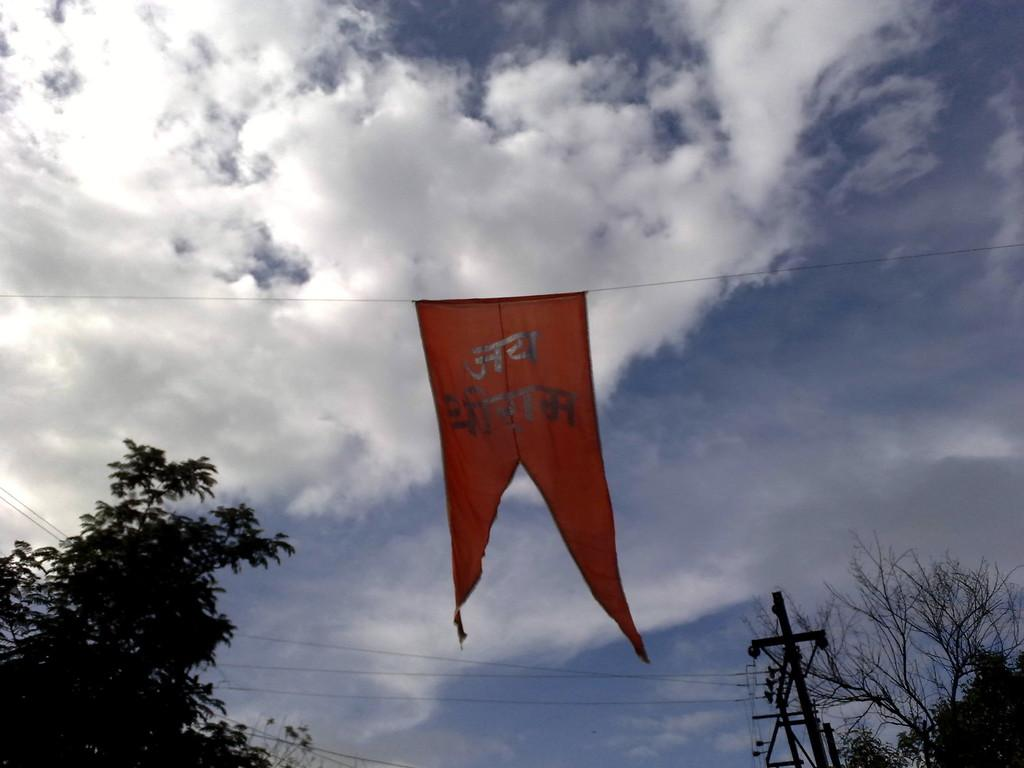What is hanging from the wire in the image? There is a red color flag on the wire. What type of vegetation can be seen on both sides of the image? There are trees on both sides of the image. What structure is present in the image? There is an electric pole in the image. What is visible at the top of the image? The sky is visible at the top of the image. What can be observed in the sky? Clouds are present in the sky. Can you see any snails crawling on the electric pole in the image? There are no snails visible on the electric pole in the image. What act is being performed by the trees in the image? The trees are not performing any act; they are simply standing in the image. 